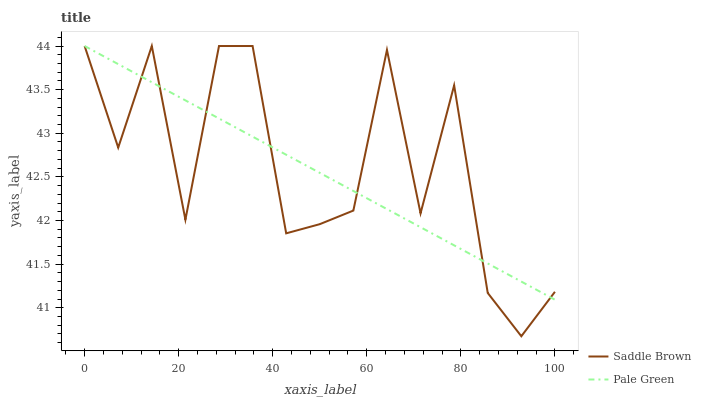Does Pale Green have the minimum area under the curve?
Answer yes or no. Yes. Does Saddle Brown have the maximum area under the curve?
Answer yes or no. Yes. Does Saddle Brown have the minimum area under the curve?
Answer yes or no. No. Is Pale Green the smoothest?
Answer yes or no. Yes. Is Saddle Brown the roughest?
Answer yes or no. Yes. Is Saddle Brown the smoothest?
Answer yes or no. No. Does Saddle Brown have the lowest value?
Answer yes or no. Yes. Does Saddle Brown have the highest value?
Answer yes or no. Yes. Does Pale Green intersect Saddle Brown?
Answer yes or no. Yes. Is Pale Green less than Saddle Brown?
Answer yes or no. No. Is Pale Green greater than Saddle Brown?
Answer yes or no. No. 